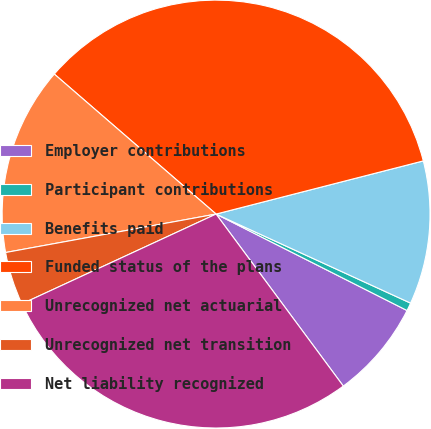Convert chart. <chart><loc_0><loc_0><loc_500><loc_500><pie_chart><fcel>Employer contributions<fcel>Participant contributions<fcel>Benefits paid<fcel>Funded status of the plans<fcel>Unrecognized net actuarial<fcel>Unrecognized net transition<fcel>Net liability recognized<nl><fcel>7.42%<fcel>0.61%<fcel>10.83%<fcel>34.65%<fcel>14.23%<fcel>4.02%<fcel>28.24%<nl></chart> 